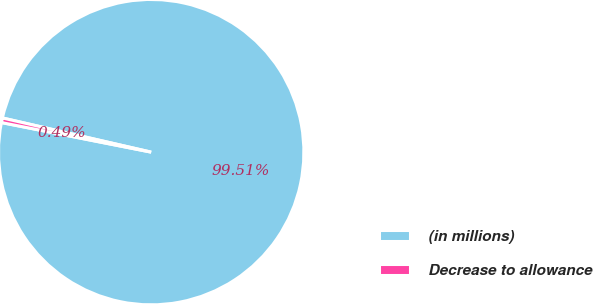<chart> <loc_0><loc_0><loc_500><loc_500><pie_chart><fcel>(in millions)<fcel>Decrease to allowance<nl><fcel>99.51%<fcel>0.49%<nl></chart> 